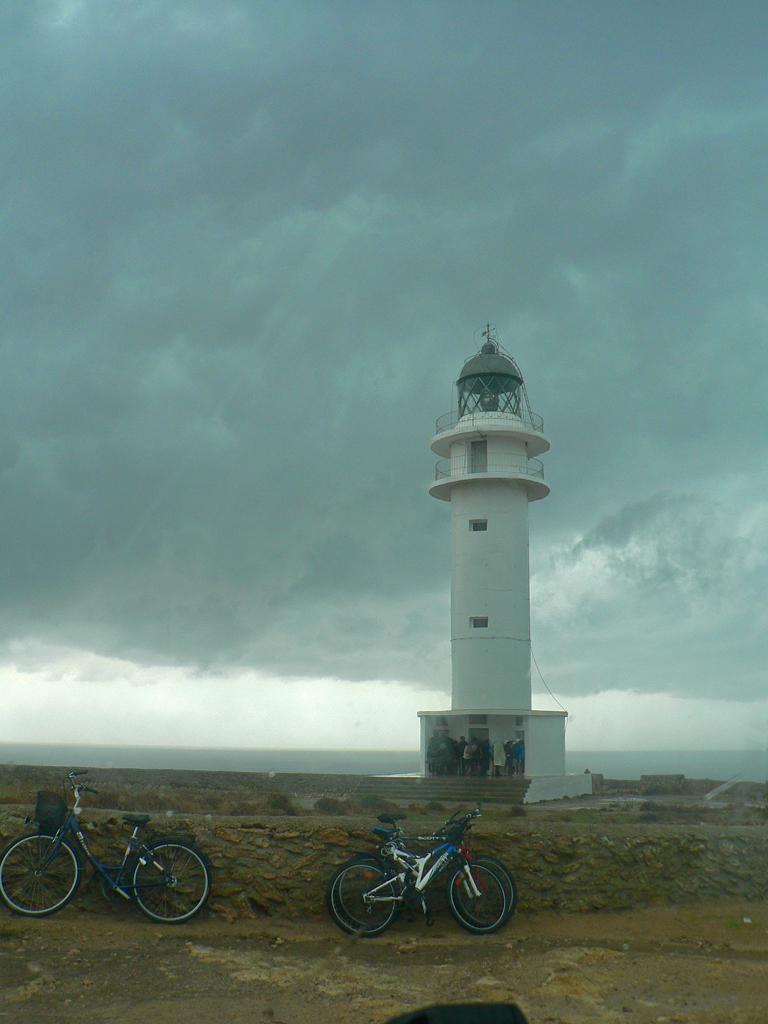Can you describe this image briefly? In this picture there is a tower on the right side of the image and there are bicycles at the bottom side of the image, there is sky at the top side of the image. 